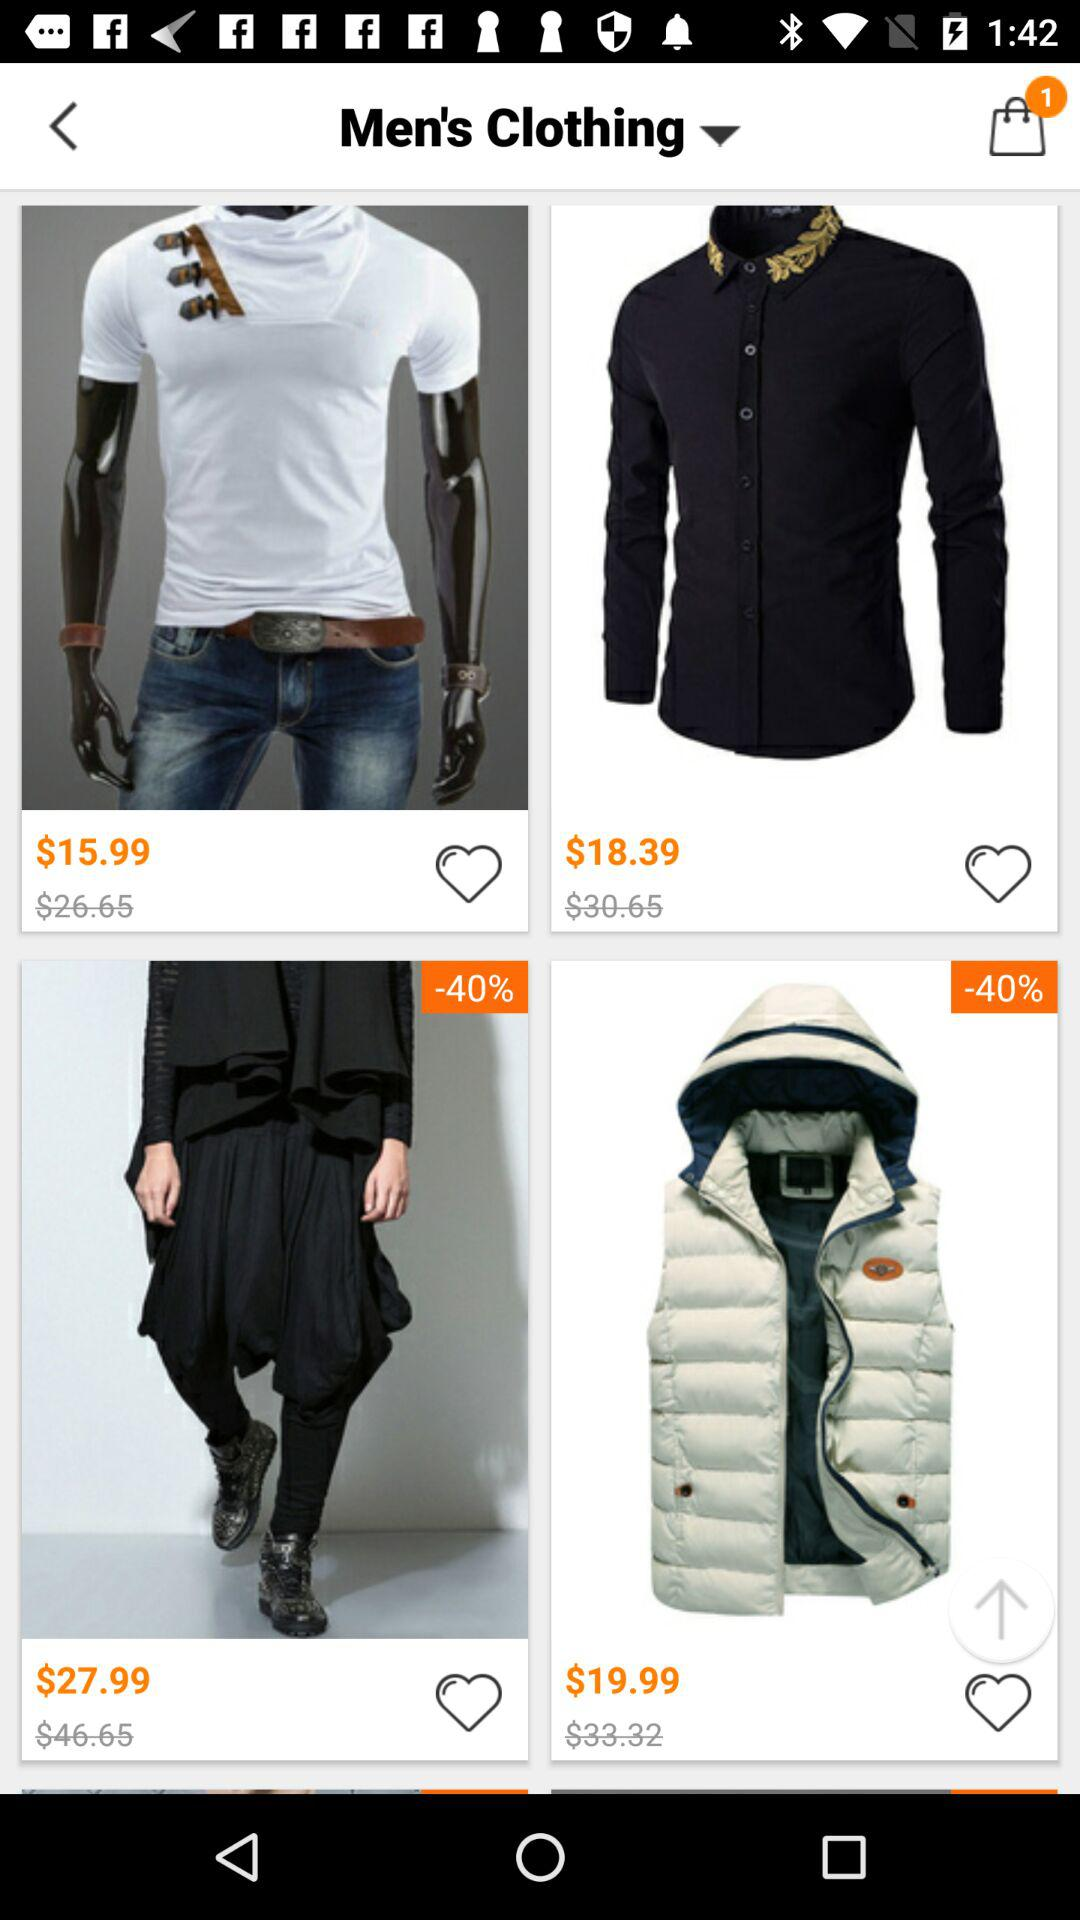How much does the men's hooded vest cost in rupees?
When the provided information is insufficient, respond with <no answer>. <no answer> 